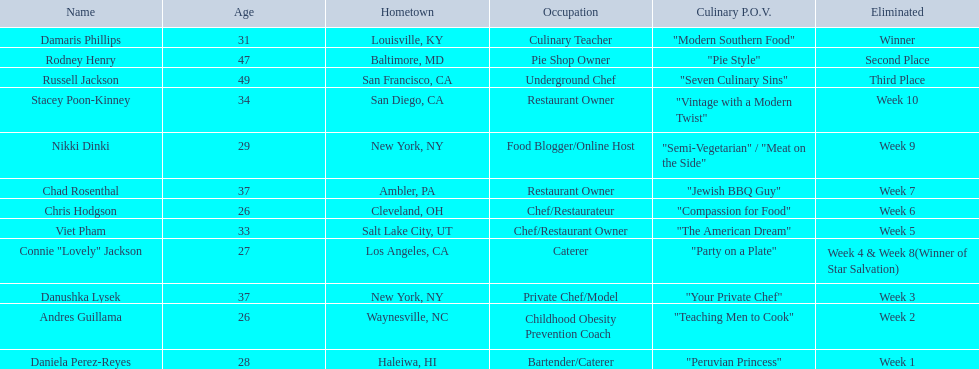Who are the culinary network celebrities? Damaris Phillips, Rodney Henry, Russell Jackson, Stacey Poon-Kinney, Nikki Dinki, Chad Rosenthal, Chris Hodgson, Viet Pham, Connie "Lovely" Jackson, Danushka Lysek, Andres Guillama, Daniela Perez-Reyes. When was nikki dinki removed? Week 9. When was viet pham disqualified? Week 5. Which week occurred earlier? Week 5. Who was the person eliminated in week 5? Viet Pham. 